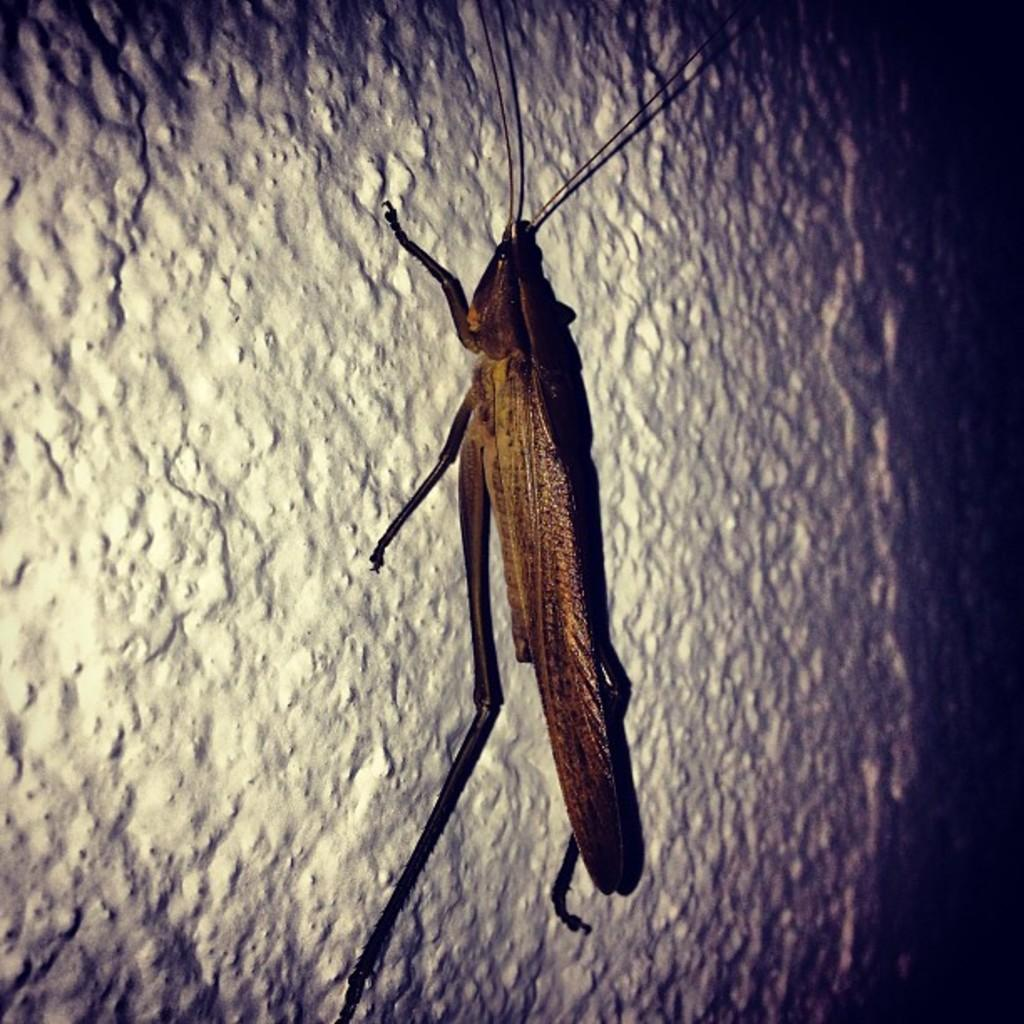What type of creature is present in the image? There is an insect in the image. Where is the insect located? The insect is on a wall. What type of street is visible in the image? There is no street present in the image; it only features an insect on a wall. What type of sail can be seen in the image? There is no sail present in the image; it only features an insect on a wall. 